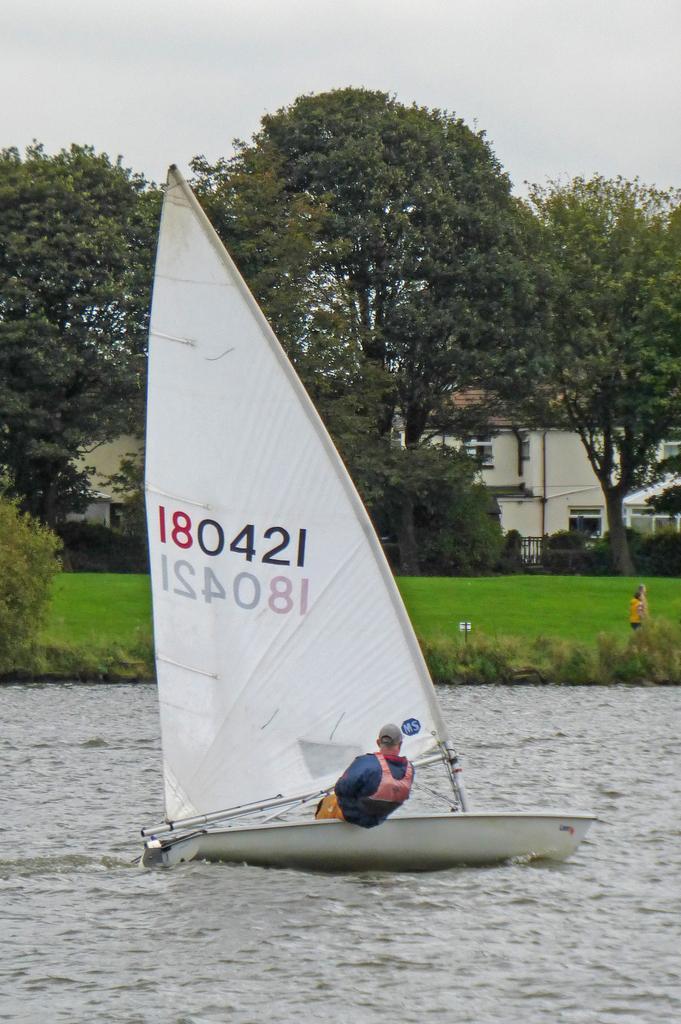Could you give a brief overview of what you see in this image? There is a person sitting on boat and we can see boat above the water. In the background we can see grass,plants,person,trees,house and sky. 